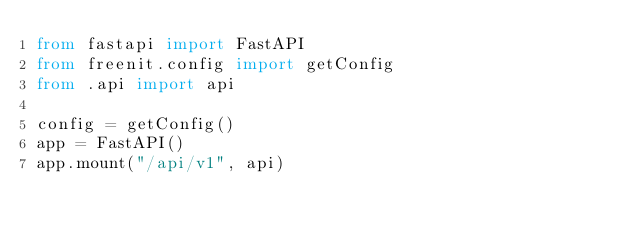Convert code to text. <code><loc_0><loc_0><loc_500><loc_500><_Python_>from fastapi import FastAPI
from freenit.config import getConfig
from .api import api

config = getConfig()
app = FastAPI()
app.mount("/api/v1", api)
</code> 